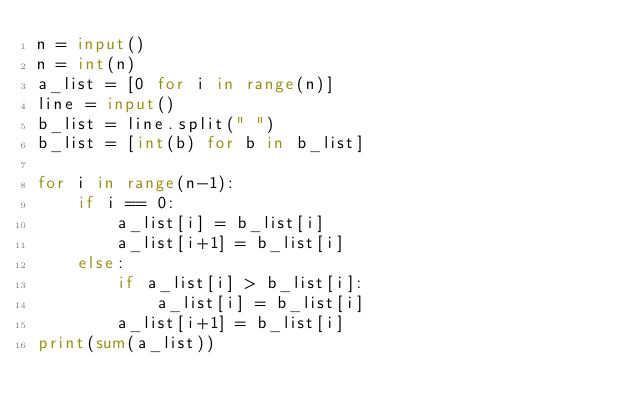Convert code to text. <code><loc_0><loc_0><loc_500><loc_500><_Python_>n = input()
n = int(n)
a_list = [0 for i in range(n)]
line = input()
b_list = line.split(" ")
b_list = [int(b) for b in b_list]

for i in range(n-1):
    if i == 0:
        a_list[i] = b_list[i]
        a_list[i+1] = b_list[i]
    else:
        if a_list[i] > b_list[i]:
            a_list[i] = b_list[i]
        a_list[i+1] = b_list[i]
print(sum(a_list))

</code> 